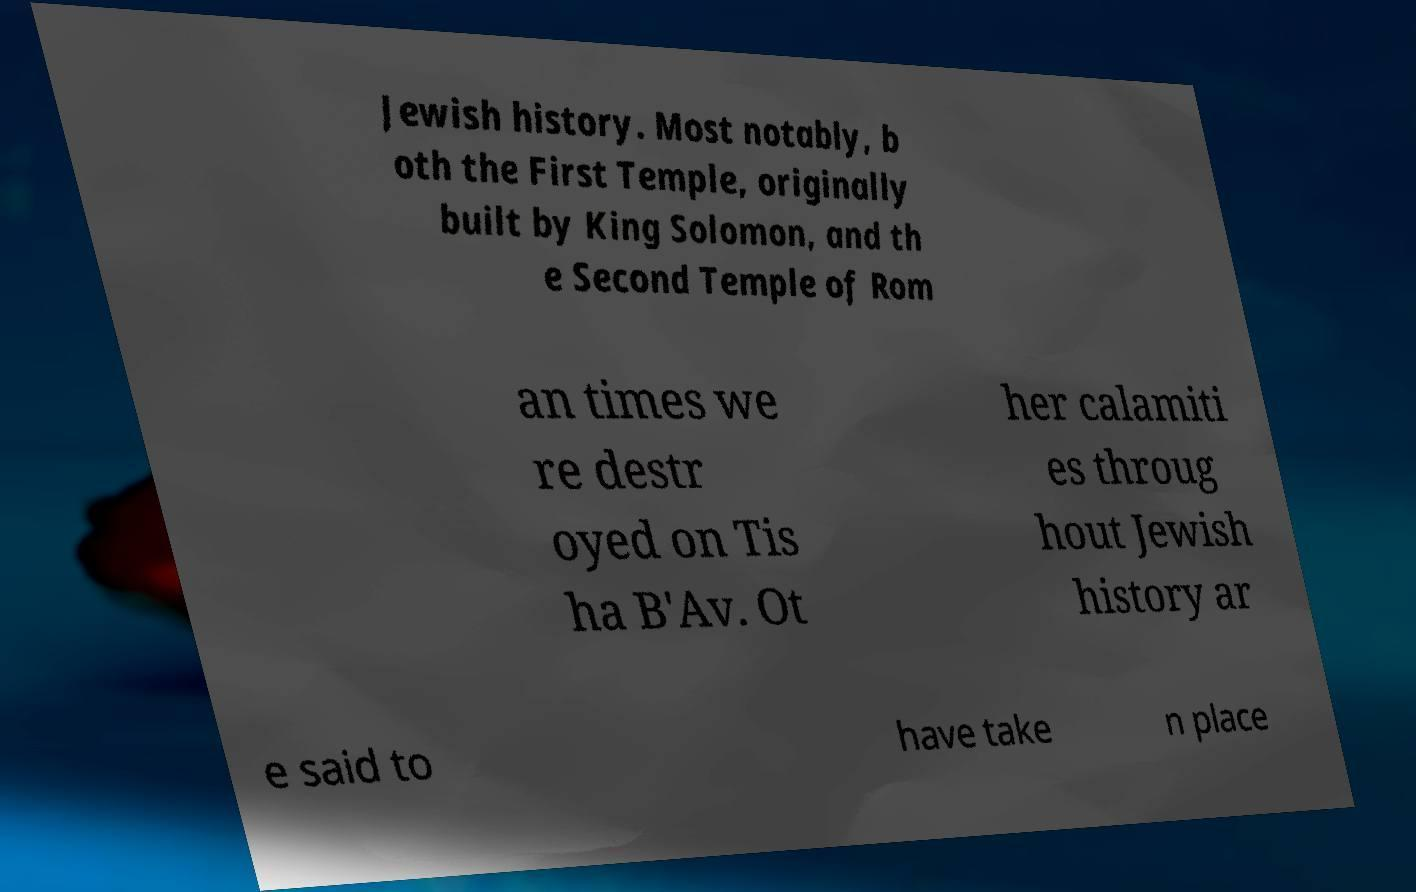Please read and relay the text visible in this image. What does it say? Jewish history. Most notably, b oth the First Temple, originally built by King Solomon, and th e Second Temple of Rom an times we re destr oyed on Tis ha B'Av. Ot her calamiti es throug hout Jewish history ar e said to have take n place 